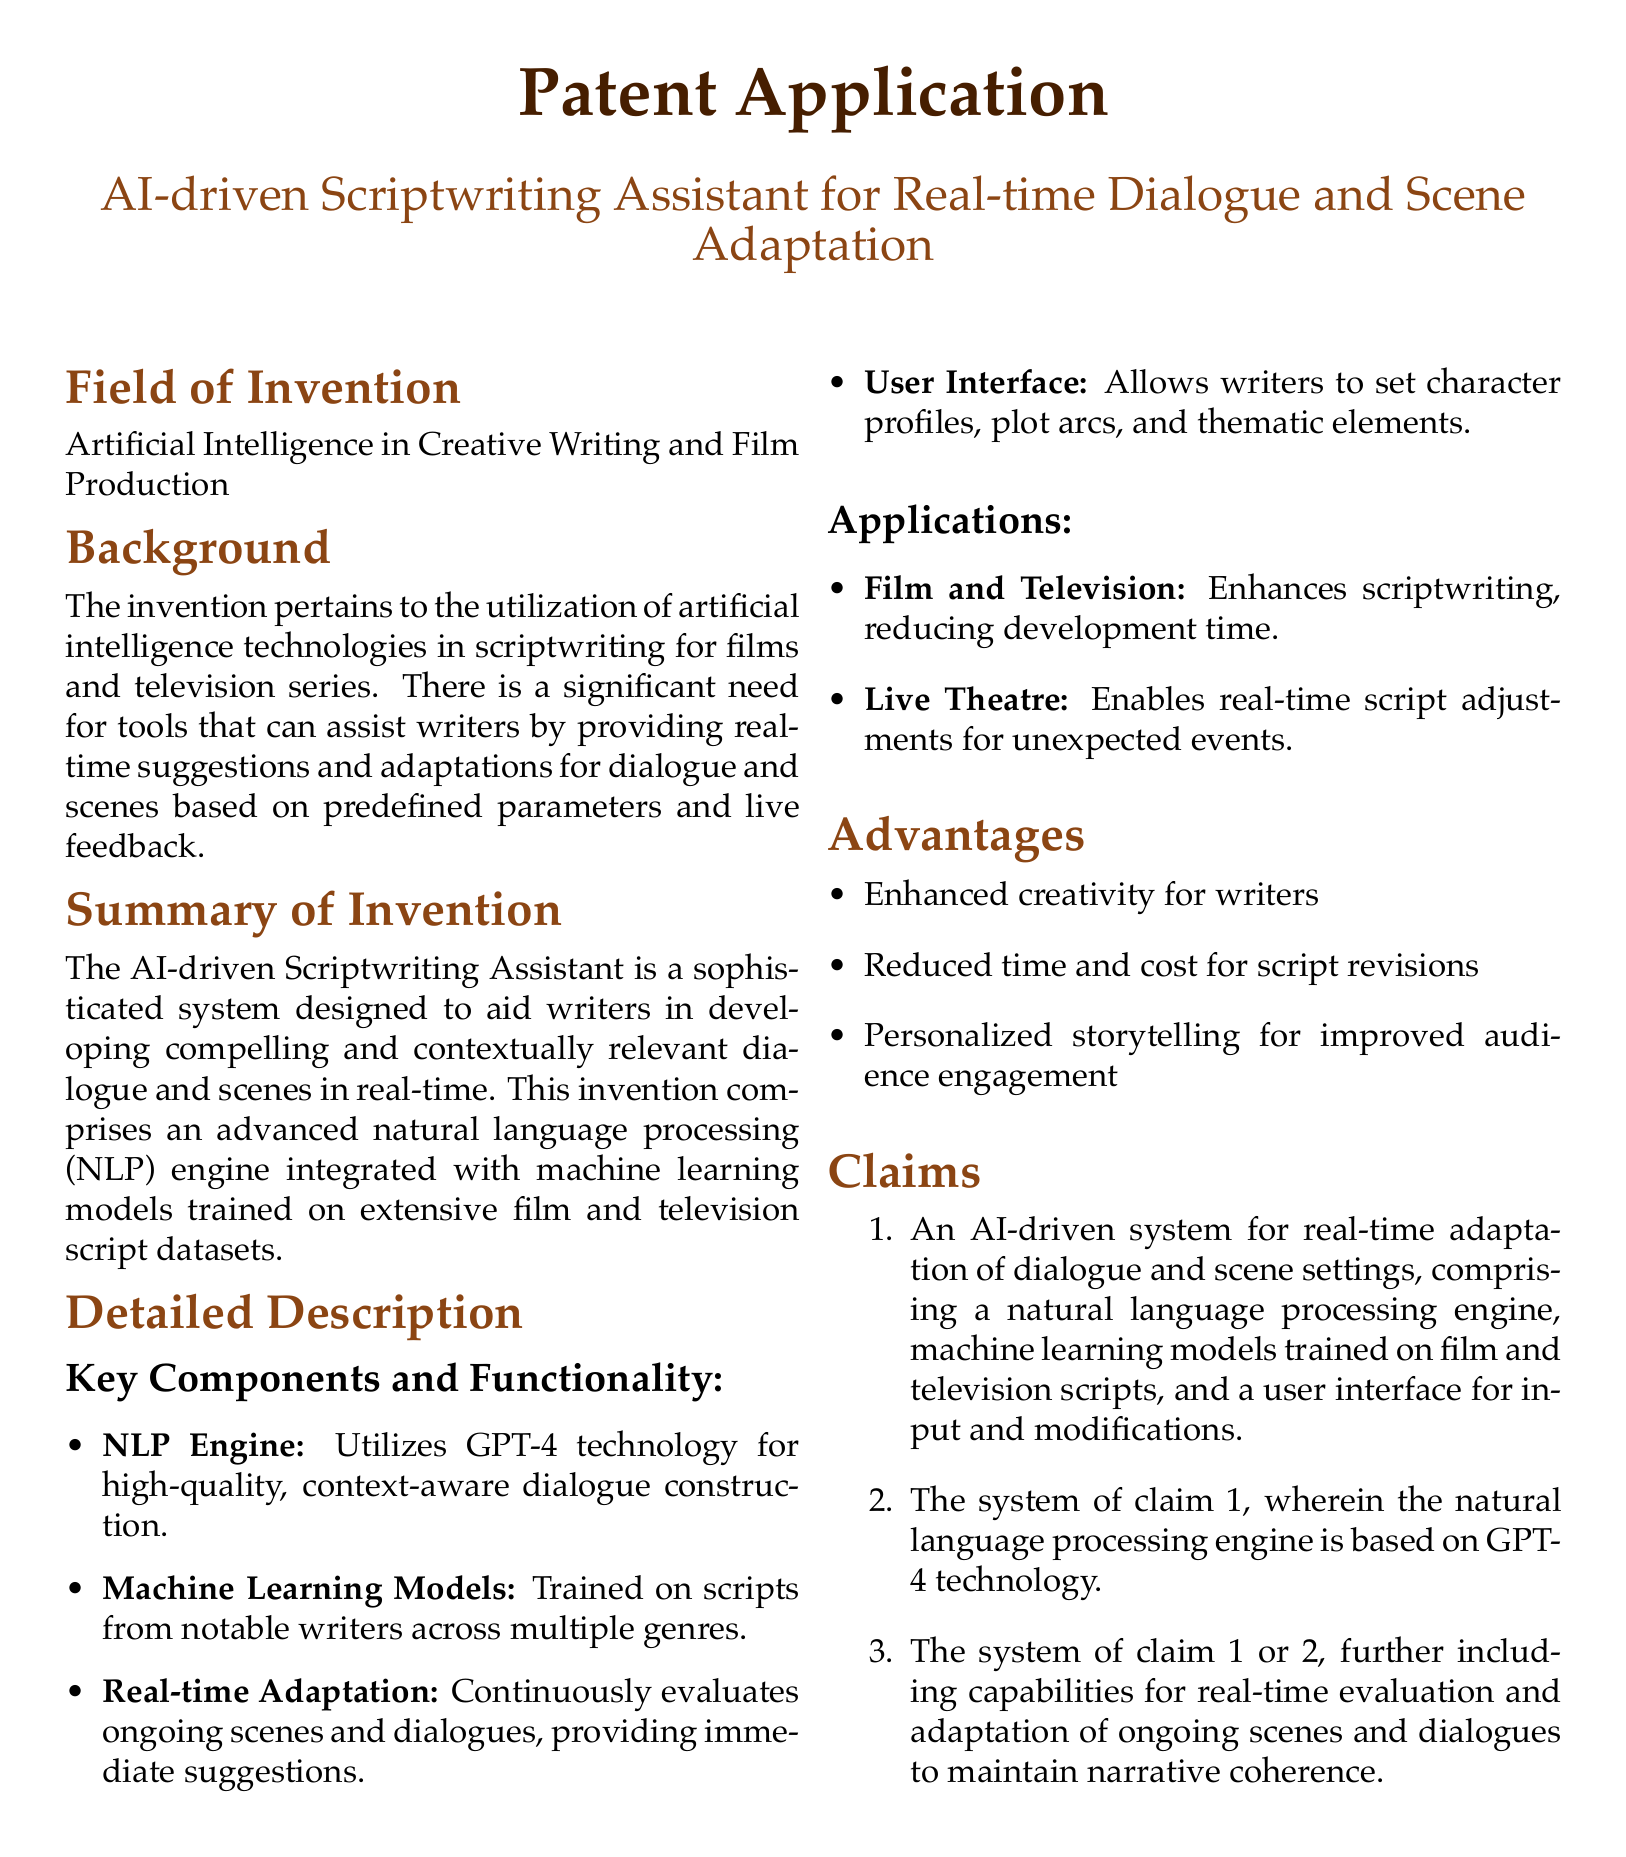What is the title of the patent application? The title of the patent application is listed at the top of the document.
Answer: AI-driven Scriptwriting Assistant for Real-time Dialogue and Scene Adaptation What technology is the NLP engine based on? The document specifically mentions the technology used for the NLP engine.
Answer: GPT-4 technology What is one of the key components of the system? The detailed description lists the key components of the system.
Answer: NLP Engine What is the main field of invention? The main field of invention is described in the first section of the document.
Answer: Artificial Intelligence in Creative Writing and Film Production How many claims are included in the document? The claims section lists the total number of claims present in the patent application.
Answer: Three claims What type of media applications does the invention support? The applications section describes the types of media the invention can enhance.
Answer: Film and Television What advantage does the system provide regarding time? The advantages section outlines how the system impacts time and cost for script revisions.
Answer: Reduced time and cost for script revisions What type of real-time feature is mentioned in the document? The detailed description includes specific functionality related to adaptation.
Answer: Real-time Adaptation What genre of content does the machine learning model train on? The background section references the type of content relevant to the training of the model.
Answer: Scripts from notable writers across multiple genres 